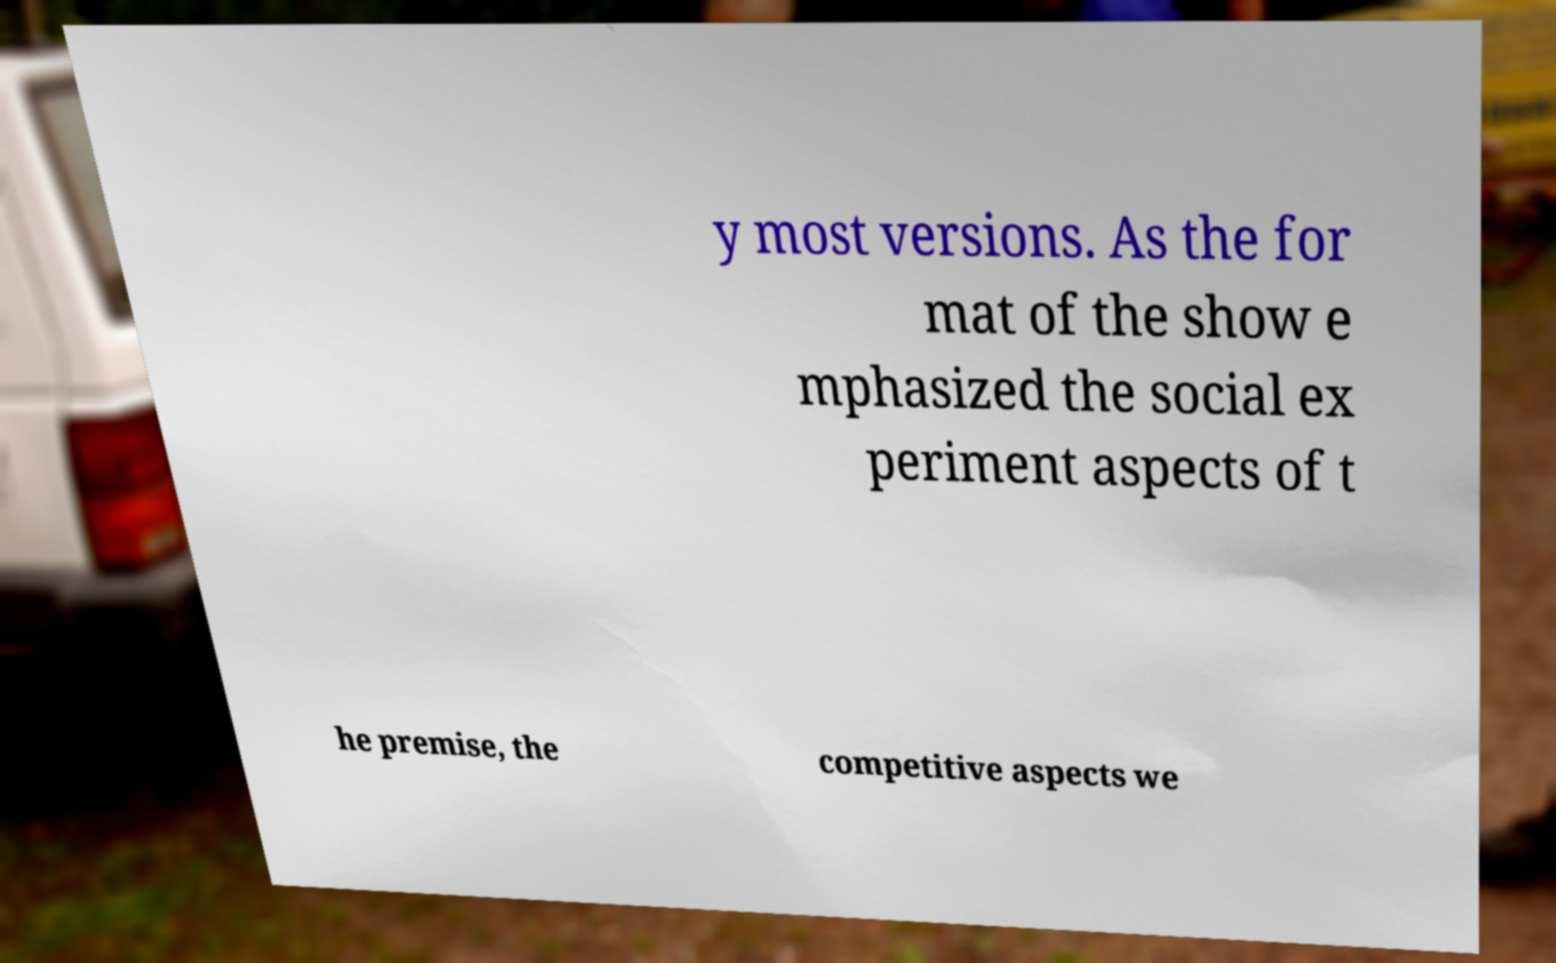Could you assist in decoding the text presented in this image and type it out clearly? y most versions. As the for mat of the show e mphasized the social ex periment aspects of t he premise, the competitive aspects we 